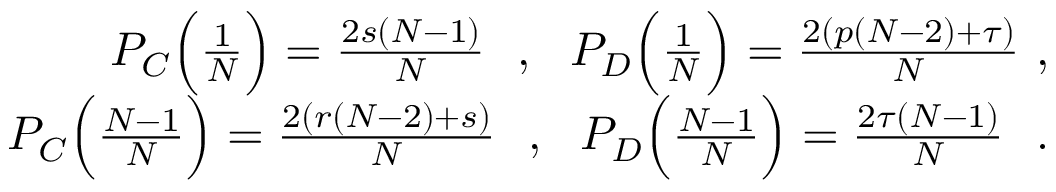Convert formula to latex. <formula><loc_0><loc_0><loc_500><loc_500>\begin{array} { r } { P _ { C } \left ( \frac { 1 } { N } \right ) = \frac { 2 s ( N - 1 ) } { N } , P _ { D } \left ( \frac { 1 } { N } \right ) = \frac { 2 ( p ( N - 2 ) + \tau ) } { N } , } \\ { P _ { C } \left ( \frac { N - 1 } { N } \right ) = \frac { 2 ( r ( N - 2 ) + s ) } { N } , P _ { D } \left ( \frac { N - 1 } { N } \right ) = \frac { 2 \tau ( N - 1 ) } { N } . } \end{array}</formula> 